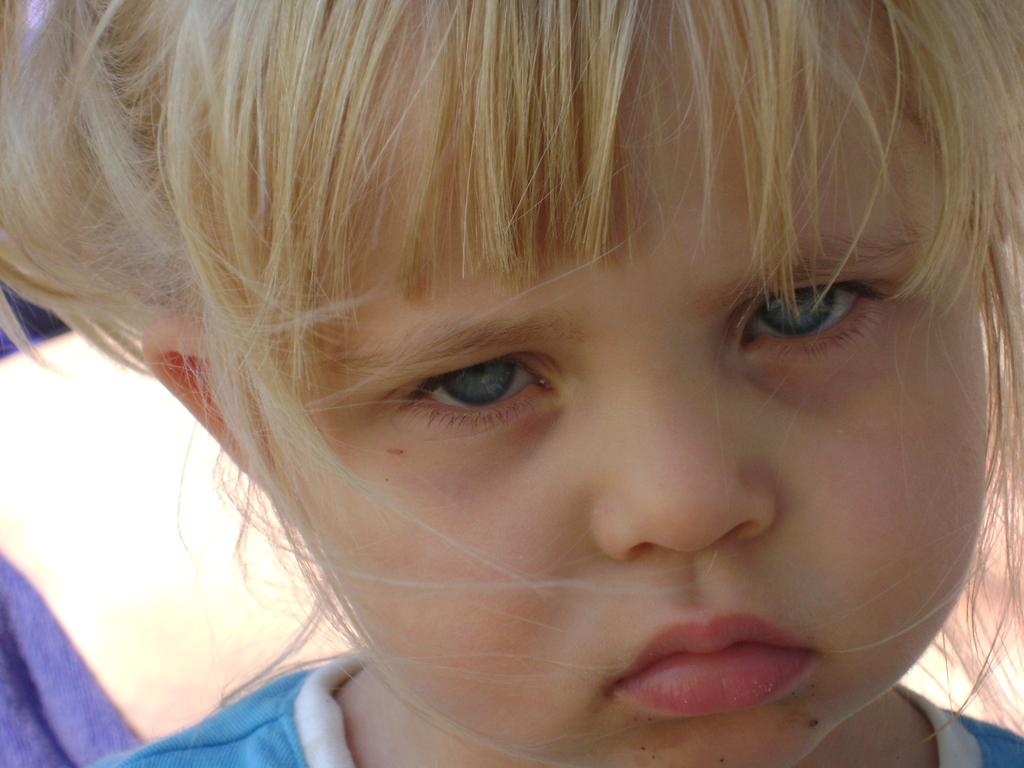What is the main subject of the image? There is a child in the image. How many trains are visible in the image? There are no trains present in the image; it features a child. What type of health advice can be seen in the image? There is no health advice present in the image; it features a child. 